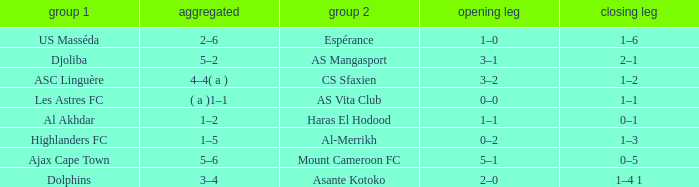What is the team 1 with team 2 Mount Cameroon FC? Ajax Cape Town. 